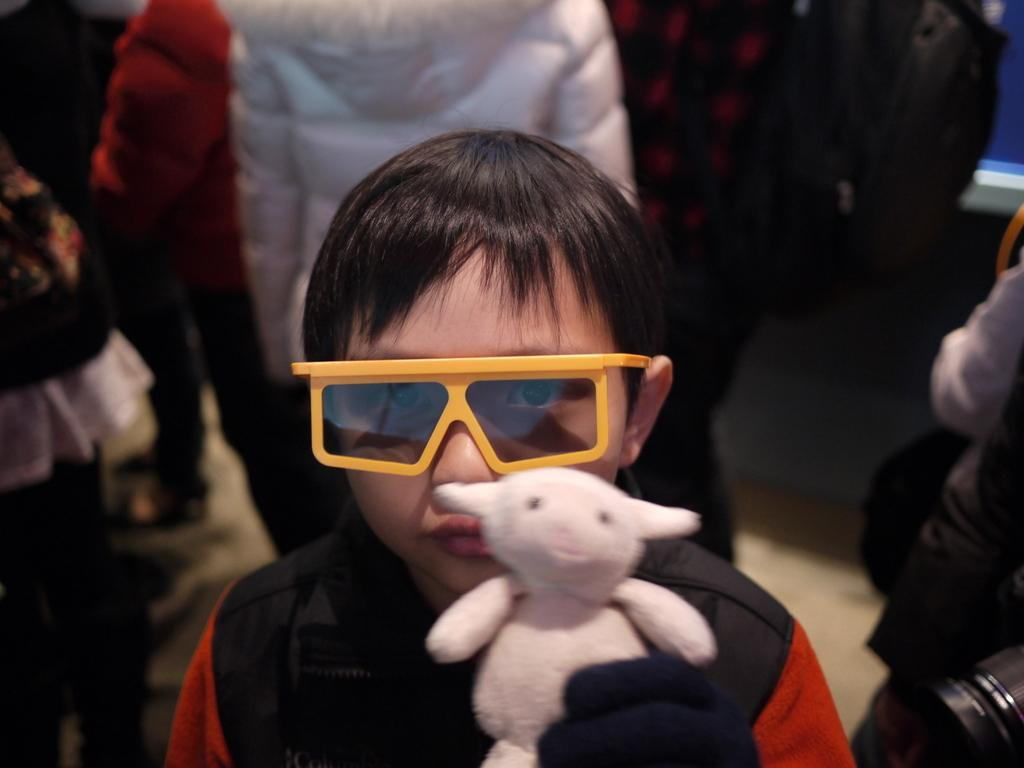Who is the main subject in the image? There is a boy in the image. What is the boy wearing? The boy is wearing goggles. What is the boy holding in the image? The boy is holding a toy. Can you describe the background of the image? There are people visible in the background of the image. What type of truck can be seen in the image? There is no truck present in the image. Is the boy using a cannon in the image? There is no cannon present in the image. 